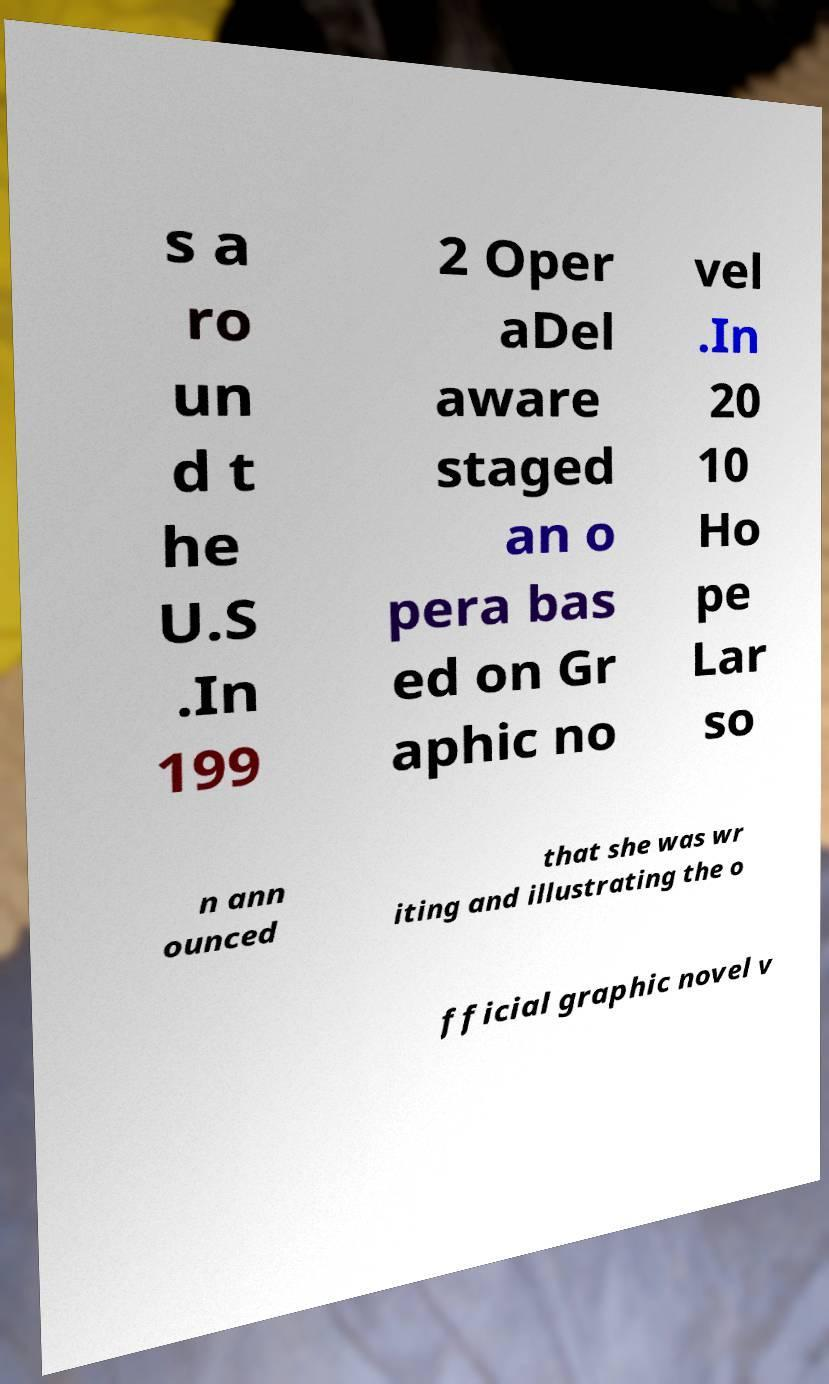Could you extract and type out the text from this image? s a ro un d t he U.S .In 199 2 Oper aDel aware staged an o pera bas ed on Gr aphic no vel .In 20 10 Ho pe Lar so n ann ounced that she was wr iting and illustrating the o fficial graphic novel v 